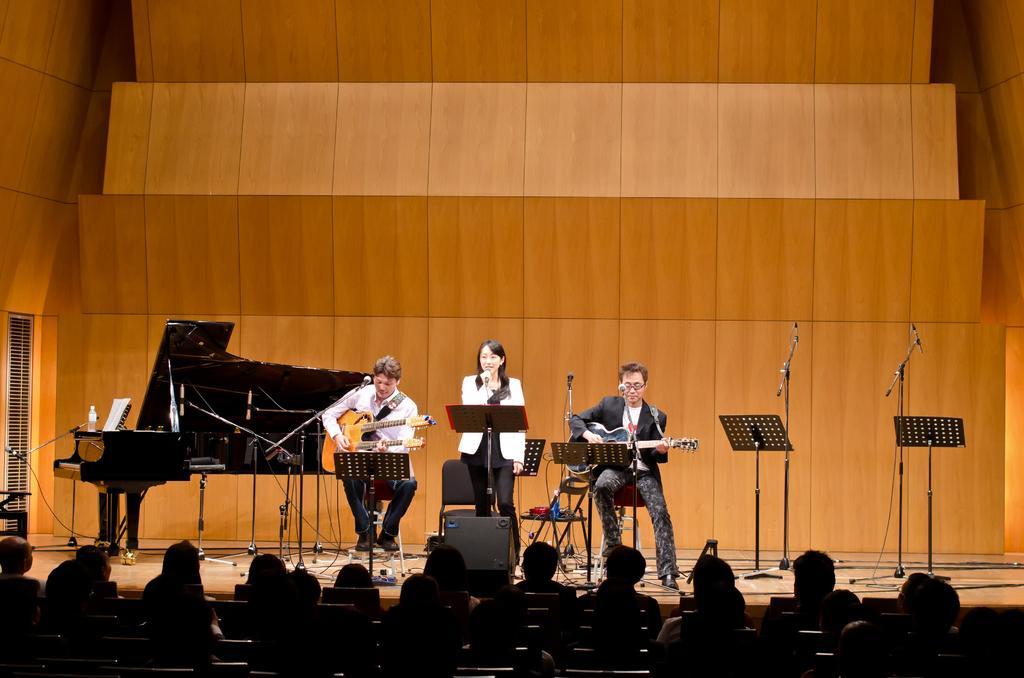Describe this image in one or two sentences. In this image I can see people where one is standing and rest all are sitting on chairs. I can see two of them are holding guitars and one is holding a mic. In the background I can see few mics, stands and a musical instrument. 